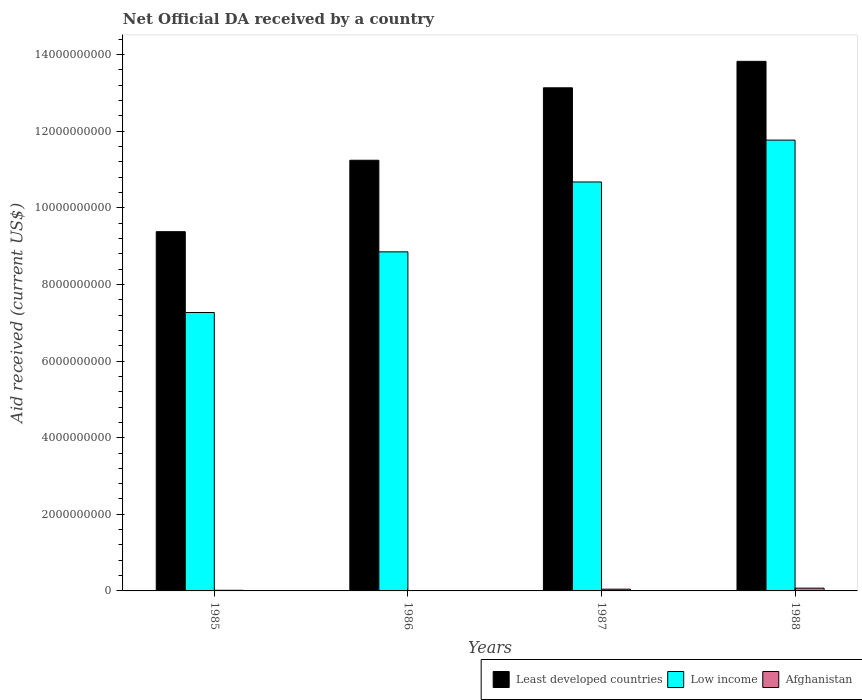Are the number of bars on each tick of the X-axis equal?
Provide a short and direct response. Yes. What is the label of the 4th group of bars from the left?
Offer a terse response. 1988. What is the net official development assistance aid received in Least developed countries in 1987?
Your response must be concise. 1.31e+1. Across all years, what is the maximum net official development assistance aid received in Low income?
Make the answer very short. 1.18e+1. Across all years, what is the minimum net official development assistance aid received in Afghanistan?
Ensure brevity in your answer.  1.91e+06. In which year was the net official development assistance aid received in Low income maximum?
Your response must be concise. 1988. In which year was the net official development assistance aid received in Low income minimum?
Your answer should be compact. 1985. What is the total net official development assistance aid received in Least developed countries in the graph?
Your answer should be very brief. 4.76e+1. What is the difference between the net official development assistance aid received in Afghanistan in 1986 and that in 1987?
Provide a short and direct response. -4.34e+07. What is the difference between the net official development assistance aid received in Low income in 1987 and the net official development assistance aid received in Least developed countries in 1985?
Your response must be concise. 1.30e+09. What is the average net official development assistance aid received in Least developed countries per year?
Keep it short and to the point. 1.19e+1. In the year 1985, what is the difference between the net official development assistance aid received in Least developed countries and net official development assistance aid received in Low income?
Ensure brevity in your answer.  2.11e+09. In how many years, is the net official development assistance aid received in Least developed countries greater than 13600000000 US$?
Provide a short and direct response. 1. What is the ratio of the net official development assistance aid received in Low income in 1985 to that in 1988?
Offer a very short reply. 0.62. Is the net official development assistance aid received in Afghanistan in 1985 less than that in 1987?
Your response must be concise. Yes. Is the difference between the net official development assistance aid received in Least developed countries in 1985 and 1988 greater than the difference between the net official development assistance aid received in Low income in 1985 and 1988?
Your answer should be compact. Yes. What is the difference between the highest and the second highest net official development assistance aid received in Low income?
Your answer should be compact. 1.09e+09. What is the difference between the highest and the lowest net official development assistance aid received in Least developed countries?
Give a very brief answer. 4.45e+09. What does the 1st bar from the right in 1987 represents?
Offer a very short reply. Afghanistan. Is it the case that in every year, the sum of the net official development assistance aid received in Least developed countries and net official development assistance aid received in Low income is greater than the net official development assistance aid received in Afghanistan?
Ensure brevity in your answer.  Yes. Are all the bars in the graph horizontal?
Ensure brevity in your answer.  No. How many years are there in the graph?
Give a very brief answer. 4. Where does the legend appear in the graph?
Offer a terse response. Bottom right. How many legend labels are there?
Give a very brief answer. 3. What is the title of the graph?
Provide a short and direct response. Net Official DA received by a country. Does "Central African Republic" appear as one of the legend labels in the graph?
Provide a succinct answer. No. What is the label or title of the Y-axis?
Provide a succinct answer. Aid received (current US$). What is the Aid received (current US$) of Least developed countries in 1985?
Your answer should be very brief. 9.38e+09. What is the Aid received (current US$) of Low income in 1985?
Offer a terse response. 7.27e+09. What is the Aid received (current US$) in Afghanistan in 1985?
Offer a very short reply. 1.63e+07. What is the Aid received (current US$) in Least developed countries in 1986?
Give a very brief answer. 1.12e+1. What is the Aid received (current US$) in Low income in 1986?
Give a very brief answer. 8.85e+09. What is the Aid received (current US$) of Afghanistan in 1986?
Ensure brevity in your answer.  1.91e+06. What is the Aid received (current US$) of Least developed countries in 1987?
Your response must be concise. 1.31e+1. What is the Aid received (current US$) of Low income in 1987?
Give a very brief answer. 1.07e+1. What is the Aid received (current US$) in Afghanistan in 1987?
Offer a very short reply. 4.53e+07. What is the Aid received (current US$) in Least developed countries in 1988?
Your answer should be compact. 1.38e+1. What is the Aid received (current US$) of Low income in 1988?
Your answer should be very brief. 1.18e+1. What is the Aid received (current US$) in Afghanistan in 1988?
Offer a terse response. 7.24e+07. Across all years, what is the maximum Aid received (current US$) of Least developed countries?
Give a very brief answer. 1.38e+1. Across all years, what is the maximum Aid received (current US$) of Low income?
Keep it short and to the point. 1.18e+1. Across all years, what is the maximum Aid received (current US$) in Afghanistan?
Your response must be concise. 7.24e+07. Across all years, what is the minimum Aid received (current US$) of Least developed countries?
Ensure brevity in your answer.  9.38e+09. Across all years, what is the minimum Aid received (current US$) in Low income?
Give a very brief answer. 7.27e+09. Across all years, what is the minimum Aid received (current US$) in Afghanistan?
Offer a very short reply. 1.91e+06. What is the total Aid received (current US$) of Least developed countries in the graph?
Your answer should be compact. 4.76e+1. What is the total Aid received (current US$) in Low income in the graph?
Your answer should be compact. 3.86e+1. What is the total Aid received (current US$) of Afghanistan in the graph?
Your response must be concise. 1.36e+08. What is the difference between the Aid received (current US$) of Least developed countries in 1985 and that in 1986?
Your answer should be compact. -1.86e+09. What is the difference between the Aid received (current US$) in Low income in 1985 and that in 1986?
Provide a succinct answer. -1.58e+09. What is the difference between the Aid received (current US$) of Afghanistan in 1985 and that in 1986?
Your answer should be very brief. 1.44e+07. What is the difference between the Aid received (current US$) in Least developed countries in 1985 and that in 1987?
Offer a very short reply. -3.76e+09. What is the difference between the Aid received (current US$) of Low income in 1985 and that in 1987?
Ensure brevity in your answer.  -3.41e+09. What is the difference between the Aid received (current US$) in Afghanistan in 1985 and that in 1987?
Provide a short and direct response. -2.90e+07. What is the difference between the Aid received (current US$) in Least developed countries in 1985 and that in 1988?
Ensure brevity in your answer.  -4.45e+09. What is the difference between the Aid received (current US$) in Low income in 1985 and that in 1988?
Keep it short and to the point. -4.50e+09. What is the difference between the Aid received (current US$) in Afghanistan in 1985 and that in 1988?
Your answer should be very brief. -5.60e+07. What is the difference between the Aid received (current US$) in Least developed countries in 1986 and that in 1987?
Provide a succinct answer. -1.89e+09. What is the difference between the Aid received (current US$) in Low income in 1986 and that in 1987?
Offer a terse response. -1.82e+09. What is the difference between the Aid received (current US$) in Afghanistan in 1986 and that in 1987?
Offer a terse response. -4.34e+07. What is the difference between the Aid received (current US$) of Least developed countries in 1986 and that in 1988?
Your response must be concise. -2.58e+09. What is the difference between the Aid received (current US$) in Low income in 1986 and that in 1988?
Make the answer very short. -2.92e+09. What is the difference between the Aid received (current US$) of Afghanistan in 1986 and that in 1988?
Keep it short and to the point. -7.04e+07. What is the difference between the Aid received (current US$) in Least developed countries in 1987 and that in 1988?
Keep it short and to the point. -6.90e+08. What is the difference between the Aid received (current US$) of Low income in 1987 and that in 1988?
Your response must be concise. -1.09e+09. What is the difference between the Aid received (current US$) in Afghanistan in 1987 and that in 1988?
Your answer should be very brief. -2.71e+07. What is the difference between the Aid received (current US$) in Least developed countries in 1985 and the Aid received (current US$) in Low income in 1986?
Offer a very short reply. 5.26e+08. What is the difference between the Aid received (current US$) of Least developed countries in 1985 and the Aid received (current US$) of Afghanistan in 1986?
Offer a terse response. 9.37e+09. What is the difference between the Aid received (current US$) in Low income in 1985 and the Aid received (current US$) in Afghanistan in 1986?
Your answer should be very brief. 7.27e+09. What is the difference between the Aid received (current US$) of Least developed countries in 1985 and the Aid received (current US$) of Low income in 1987?
Provide a succinct answer. -1.30e+09. What is the difference between the Aid received (current US$) in Least developed countries in 1985 and the Aid received (current US$) in Afghanistan in 1987?
Keep it short and to the point. 9.33e+09. What is the difference between the Aid received (current US$) of Low income in 1985 and the Aid received (current US$) of Afghanistan in 1987?
Give a very brief answer. 7.22e+09. What is the difference between the Aid received (current US$) of Least developed countries in 1985 and the Aid received (current US$) of Low income in 1988?
Your answer should be very brief. -2.39e+09. What is the difference between the Aid received (current US$) of Least developed countries in 1985 and the Aid received (current US$) of Afghanistan in 1988?
Offer a very short reply. 9.30e+09. What is the difference between the Aid received (current US$) of Low income in 1985 and the Aid received (current US$) of Afghanistan in 1988?
Ensure brevity in your answer.  7.20e+09. What is the difference between the Aid received (current US$) of Least developed countries in 1986 and the Aid received (current US$) of Low income in 1987?
Offer a very short reply. 5.67e+08. What is the difference between the Aid received (current US$) in Least developed countries in 1986 and the Aid received (current US$) in Afghanistan in 1987?
Provide a succinct answer. 1.12e+1. What is the difference between the Aid received (current US$) in Low income in 1986 and the Aid received (current US$) in Afghanistan in 1987?
Keep it short and to the point. 8.81e+09. What is the difference between the Aid received (current US$) of Least developed countries in 1986 and the Aid received (current US$) of Low income in 1988?
Your response must be concise. -5.25e+08. What is the difference between the Aid received (current US$) of Least developed countries in 1986 and the Aid received (current US$) of Afghanistan in 1988?
Your answer should be compact. 1.12e+1. What is the difference between the Aid received (current US$) of Low income in 1986 and the Aid received (current US$) of Afghanistan in 1988?
Your answer should be compact. 8.78e+09. What is the difference between the Aid received (current US$) in Least developed countries in 1987 and the Aid received (current US$) in Low income in 1988?
Offer a very short reply. 1.37e+09. What is the difference between the Aid received (current US$) in Least developed countries in 1987 and the Aid received (current US$) in Afghanistan in 1988?
Keep it short and to the point. 1.31e+1. What is the difference between the Aid received (current US$) in Low income in 1987 and the Aid received (current US$) in Afghanistan in 1988?
Provide a succinct answer. 1.06e+1. What is the average Aid received (current US$) in Least developed countries per year?
Offer a terse response. 1.19e+1. What is the average Aid received (current US$) of Low income per year?
Ensure brevity in your answer.  9.64e+09. What is the average Aid received (current US$) in Afghanistan per year?
Provide a succinct answer. 3.40e+07. In the year 1985, what is the difference between the Aid received (current US$) of Least developed countries and Aid received (current US$) of Low income?
Offer a terse response. 2.11e+09. In the year 1985, what is the difference between the Aid received (current US$) in Least developed countries and Aid received (current US$) in Afghanistan?
Provide a short and direct response. 9.36e+09. In the year 1985, what is the difference between the Aid received (current US$) in Low income and Aid received (current US$) in Afghanistan?
Offer a terse response. 7.25e+09. In the year 1986, what is the difference between the Aid received (current US$) of Least developed countries and Aid received (current US$) of Low income?
Give a very brief answer. 2.39e+09. In the year 1986, what is the difference between the Aid received (current US$) in Least developed countries and Aid received (current US$) in Afghanistan?
Provide a succinct answer. 1.12e+1. In the year 1986, what is the difference between the Aid received (current US$) in Low income and Aid received (current US$) in Afghanistan?
Your answer should be compact. 8.85e+09. In the year 1987, what is the difference between the Aid received (current US$) in Least developed countries and Aid received (current US$) in Low income?
Your answer should be compact. 2.46e+09. In the year 1987, what is the difference between the Aid received (current US$) in Least developed countries and Aid received (current US$) in Afghanistan?
Your answer should be compact. 1.31e+1. In the year 1987, what is the difference between the Aid received (current US$) of Low income and Aid received (current US$) of Afghanistan?
Ensure brevity in your answer.  1.06e+1. In the year 1988, what is the difference between the Aid received (current US$) in Least developed countries and Aid received (current US$) in Low income?
Your answer should be compact. 2.06e+09. In the year 1988, what is the difference between the Aid received (current US$) of Least developed countries and Aid received (current US$) of Afghanistan?
Keep it short and to the point. 1.38e+1. In the year 1988, what is the difference between the Aid received (current US$) in Low income and Aid received (current US$) in Afghanistan?
Give a very brief answer. 1.17e+1. What is the ratio of the Aid received (current US$) in Least developed countries in 1985 to that in 1986?
Your response must be concise. 0.83. What is the ratio of the Aid received (current US$) of Low income in 1985 to that in 1986?
Offer a terse response. 0.82. What is the ratio of the Aid received (current US$) of Afghanistan in 1985 to that in 1986?
Offer a very short reply. 8.54. What is the ratio of the Aid received (current US$) in Least developed countries in 1985 to that in 1987?
Your response must be concise. 0.71. What is the ratio of the Aid received (current US$) of Low income in 1985 to that in 1987?
Provide a short and direct response. 0.68. What is the ratio of the Aid received (current US$) of Afghanistan in 1985 to that in 1987?
Your response must be concise. 0.36. What is the ratio of the Aid received (current US$) in Least developed countries in 1985 to that in 1988?
Your answer should be compact. 0.68. What is the ratio of the Aid received (current US$) of Low income in 1985 to that in 1988?
Provide a succinct answer. 0.62. What is the ratio of the Aid received (current US$) of Afghanistan in 1985 to that in 1988?
Provide a short and direct response. 0.23. What is the ratio of the Aid received (current US$) of Least developed countries in 1986 to that in 1987?
Give a very brief answer. 0.86. What is the ratio of the Aid received (current US$) in Low income in 1986 to that in 1987?
Make the answer very short. 0.83. What is the ratio of the Aid received (current US$) of Afghanistan in 1986 to that in 1987?
Provide a succinct answer. 0.04. What is the ratio of the Aid received (current US$) of Least developed countries in 1986 to that in 1988?
Give a very brief answer. 0.81. What is the ratio of the Aid received (current US$) in Low income in 1986 to that in 1988?
Your answer should be compact. 0.75. What is the ratio of the Aid received (current US$) of Afghanistan in 1986 to that in 1988?
Provide a short and direct response. 0.03. What is the ratio of the Aid received (current US$) in Least developed countries in 1987 to that in 1988?
Keep it short and to the point. 0.95. What is the ratio of the Aid received (current US$) of Low income in 1987 to that in 1988?
Your response must be concise. 0.91. What is the ratio of the Aid received (current US$) in Afghanistan in 1987 to that in 1988?
Your response must be concise. 0.63. What is the difference between the highest and the second highest Aid received (current US$) of Least developed countries?
Your response must be concise. 6.90e+08. What is the difference between the highest and the second highest Aid received (current US$) of Low income?
Keep it short and to the point. 1.09e+09. What is the difference between the highest and the second highest Aid received (current US$) in Afghanistan?
Your answer should be very brief. 2.71e+07. What is the difference between the highest and the lowest Aid received (current US$) in Least developed countries?
Your answer should be compact. 4.45e+09. What is the difference between the highest and the lowest Aid received (current US$) of Low income?
Give a very brief answer. 4.50e+09. What is the difference between the highest and the lowest Aid received (current US$) in Afghanistan?
Make the answer very short. 7.04e+07. 